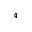<formula> <loc_0><loc_0><loc_500><loc_500>_ { 4 }</formula> 